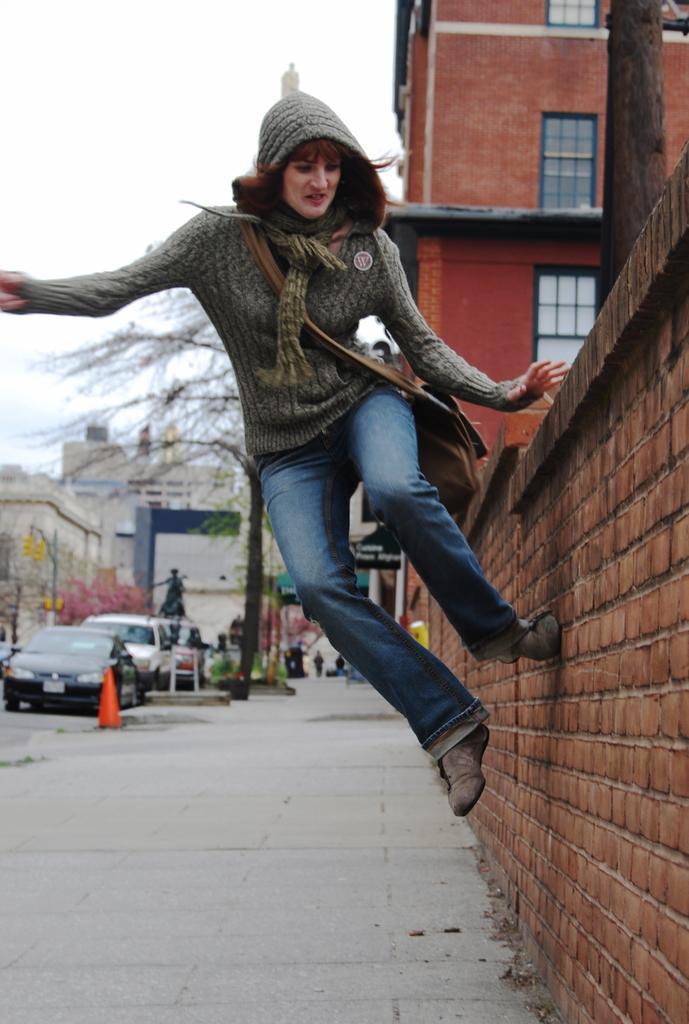Please provide a concise description of this image. In this image I can see building , wall and a person visible, on the left side there are buildings , vehicles, trees at the top there is the sky visible. 